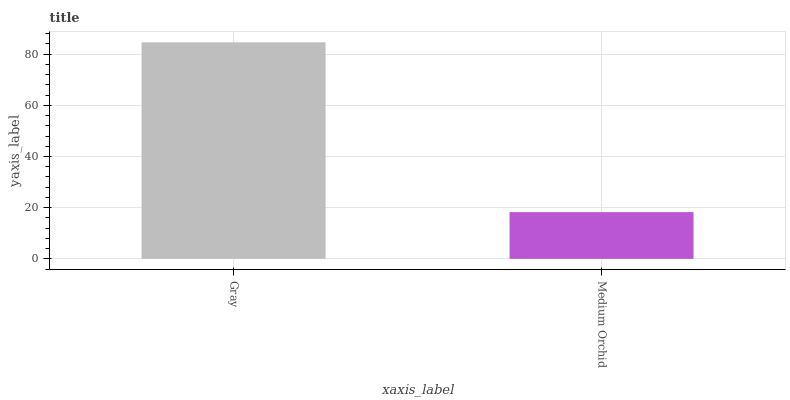Is Medium Orchid the minimum?
Answer yes or no. Yes. Is Gray the maximum?
Answer yes or no. Yes. Is Medium Orchid the maximum?
Answer yes or no. No. Is Gray greater than Medium Orchid?
Answer yes or no. Yes. Is Medium Orchid less than Gray?
Answer yes or no. Yes. Is Medium Orchid greater than Gray?
Answer yes or no. No. Is Gray less than Medium Orchid?
Answer yes or no. No. Is Gray the high median?
Answer yes or no. Yes. Is Medium Orchid the low median?
Answer yes or no. Yes. Is Medium Orchid the high median?
Answer yes or no. No. Is Gray the low median?
Answer yes or no. No. 